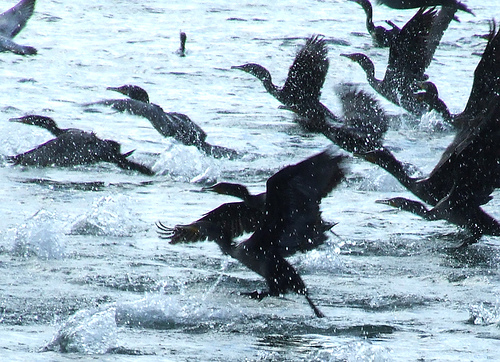Please provide the bounding box coordinate of the region this sentence describes: water droplets landing on a bird. The bounding box coordinates for the area where 'water droplets landing on a bird' are visible are [0.83, 0.55, 0.86, 0.58]. This small area shows the moment when droplets make contact with the bird. 